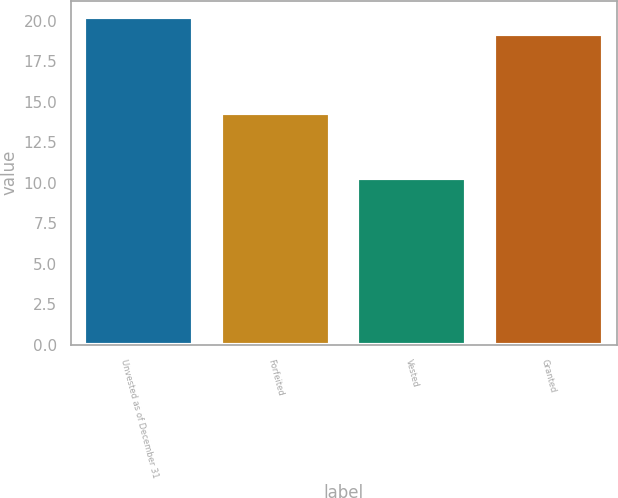<chart> <loc_0><loc_0><loc_500><loc_500><bar_chart><fcel>Unvested as of December 31<fcel>Forfeited<fcel>Vested<fcel>Granted<nl><fcel>20.21<fcel>14.27<fcel>10.31<fcel>19.16<nl></chart> 